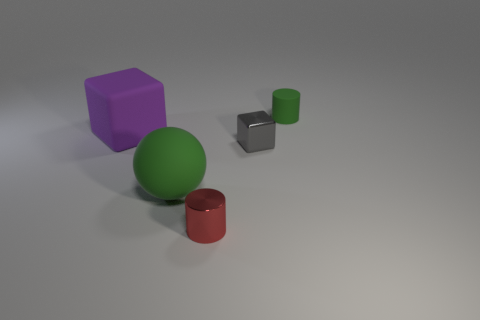Is there anything else that is the same color as the tiny cube?
Your answer should be very brief. No. Is the number of small metal cylinders greater than the number of big yellow cubes?
Keep it short and to the point. Yes. Do the small green object and the large purple thing have the same material?
Your response must be concise. Yes. What number of large brown things are the same material as the sphere?
Your answer should be very brief. 0. Does the green rubber cylinder have the same size as the cylinder in front of the green matte sphere?
Provide a short and direct response. Yes. There is a small thing that is both in front of the purple matte block and behind the red object; what is its color?
Keep it short and to the point. Gray. Is the number of blocks the same as the number of large green objects?
Make the answer very short. No. There is a shiny object that is in front of the small gray block; is there a rubber cylinder that is in front of it?
Ensure brevity in your answer.  No. Are there an equal number of matte cylinders behind the small gray shiny block and large green rubber balls?
Keep it short and to the point. Yes. What number of small gray things are to the right of the cube that is on the right side of the green thing that is to the left of the tiny green rubber thing?
Your answer should be very brief. 0. 